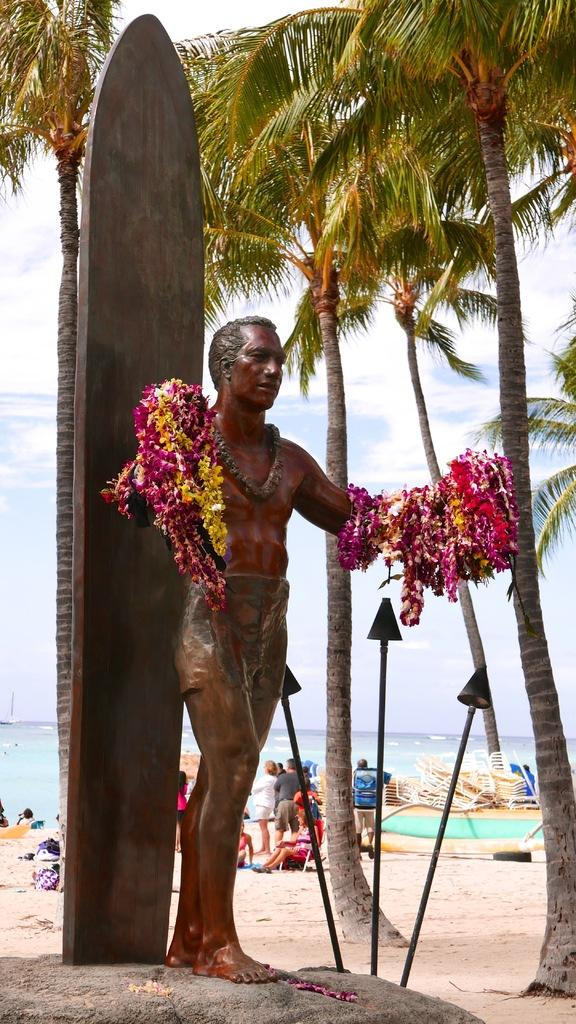What is the main subject in the image? There is a statue in the image. What other elements can be seen in the image? There are flowers, a tree, and people in the background of the image. What can be seen in the distance in the image? There is a sea and the sky visible in the background of the image. Where is the scarecrow located in the image? There is no scarecrow present in the image. What type of fruit is the quince growing on the tree in the image? There is no quince mentioned or visible in the image; the tree is not specified as a quince tree. 